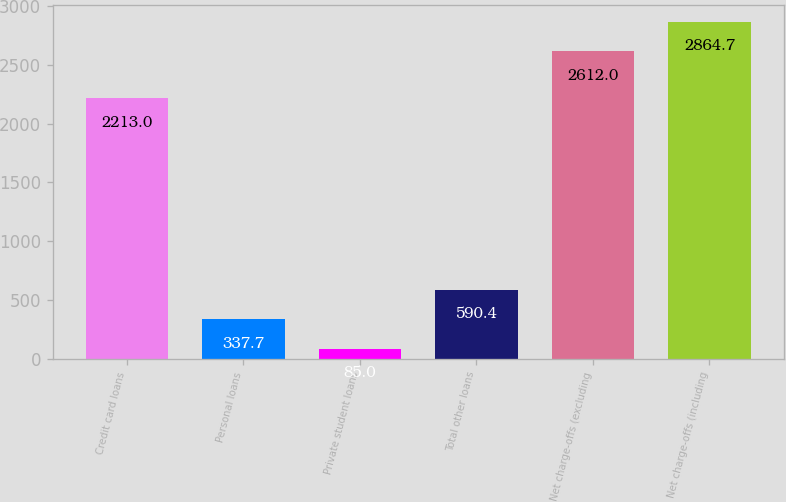Convert chart. <chart><loc_0><loc_0><loc_500><loc_500><bar_chart><fcel>Credit card loans<fcel>Personal loans<fcel>Private student loans<fcel>Total other loans<fcel>Net charge-offs (excluding<fcel>Net charge-offs (including<nl><fcel>2213<fcel>337.7<fcel>85<fcel>590.4<fcel>2612<fcel>2864.7<nl></chart> 